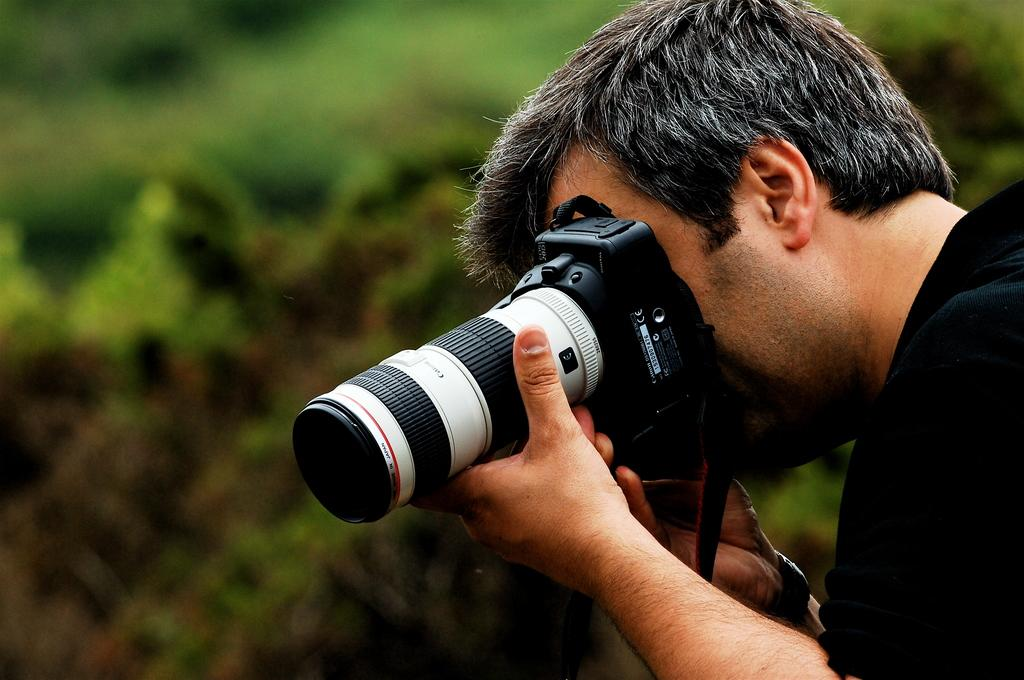Who is present in the image? There is a man in the image. What is the man wearing? The man is wearing a black t-shirt. What is the man holding in the image? The man is holding a microphone. Can you describe the background of the image? The background of the image is blurry. Is there a playground visible in the background of the image? No, there is no playground present in the image. 